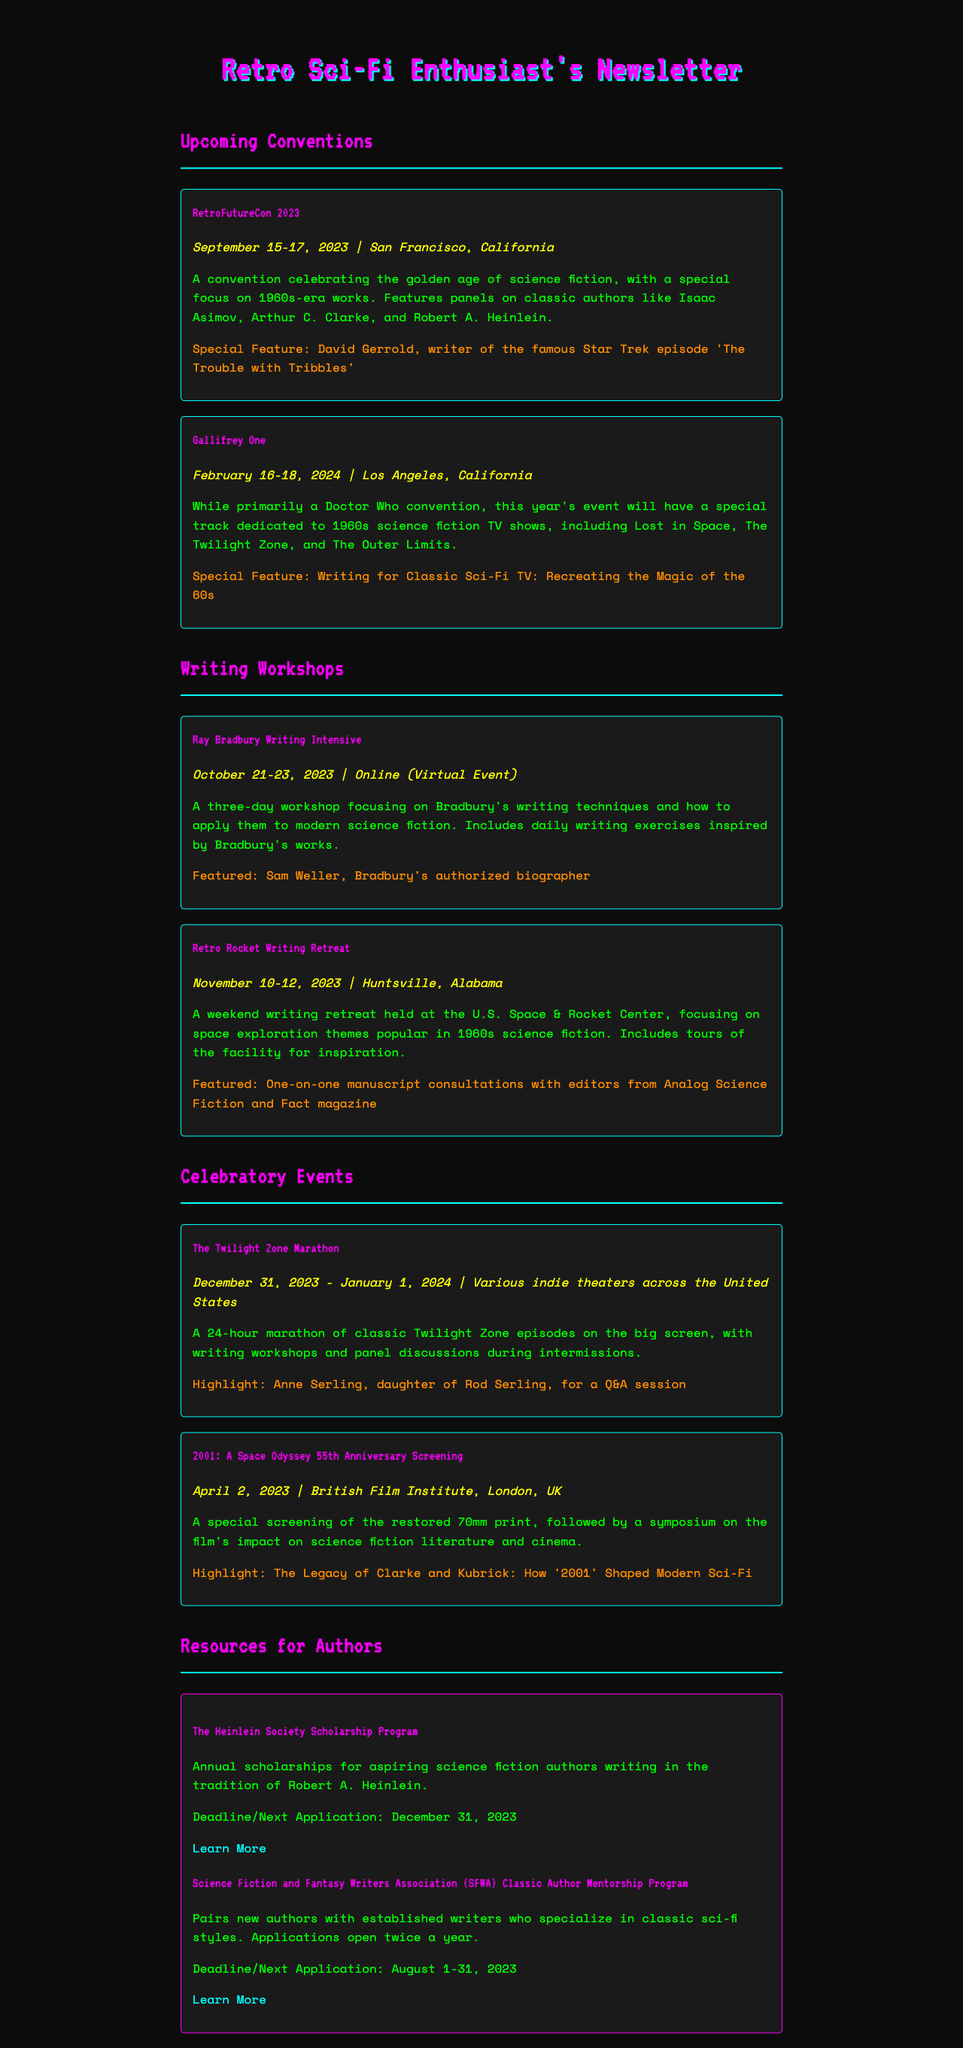What is the name of the convention celebrating 1960s science fiction? The document lists "RetroFutureCon 2023" as a convention celebrating the golden age of science fiction, with a focus on the 1960s.
Answer: RetroFutureCon 2023 Who is the special guest at Gallifrey One? The document mentions that while Gallifrey One is primarily a Doctor Who convention, it features a special track on 1960s sci-fi, but does not specify a special guest.
Answer: TBA When is the Ray Bradbury Writing Intensive taking place? The workshop is scheduled for October 21-23, 2023, as stated in the document.
Answer: October 21-23, 2023 Where is the Retro Rocket Writing Retreat held? The document indicates that this retreat will be held at the U.S. Space & Rocket Center in Huntsville, Alabama.
Answer: Huntsville, Alabama What unique feature does the "Twilight Zone Marathon" offer? The document states that the marathon will include writing workshops and panel discussions during intermissions, in addition to the marathon itself.
Answer: Writing workshops How long will The Twilight Zone Marathon last? The event is described as a 24-hour marathon, which is noted in the document.
Answer: 24 hours What is the date for the 2001: A Space Odyssey 55th Anniversary Screening? The document specifies that this special screening will take place on April 2, 2023.
Answer: April 2, 2023 What scholarship program is mentioned for aspiring science fiction authors? The document details "The Heinlein Society Scholarship Program" as an opportunity for aspiring authors.
Answer: The Heinlein Society Scholarship Program What is the purpose of the Science Fiction and Fantasy Writers Association's mentorship program? The document states that this program pairs new authors with established writers specializing in classic sci-fi styles, highlighting its networking aspect.
Answer: Networking 